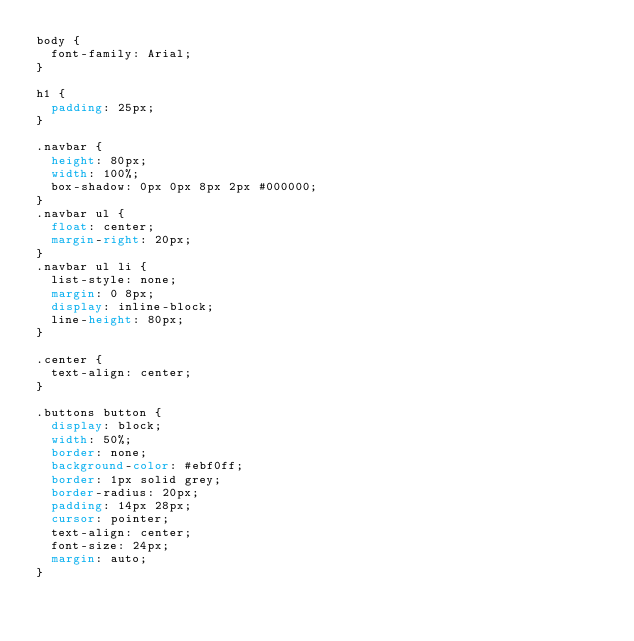Convert code to text. <code><loc_0><loc_0><loc_500><loc_500><_CSS_>body {
	font-family: Arial;
}

h1 {
	padding: 25px;
}

.navbar {
	height: 80px;
	width: 100%;
	box-shadow: 0px 0px 8px 2px #000000;
}
.navbar ul {
	float: center;
	margin-right: 20px;
}
.navbar ul li {
	list-style: none;
	margin: 0 8px;
	display: inline-block;
	line-height: 80px;
}

.center {
	text-align: center;
}

.buttons button {
	display: block;
	width: 50%;
	border: none;
	background-color: #ebf0ff;
	border: 1px solid grey;
	border-radius: 20px;
	padding: 14px 28px;
	cursor: pointer;
	text-align: center;
	font-size: 24px;
	margin: auto;
}</code> 